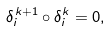<formula> <loc_0><loc_0><loc_500><loc_500>\delta _ { i } ^ { k + 1 } \circ \delta _ { i } ^ { k } = 0 ,</formula> 